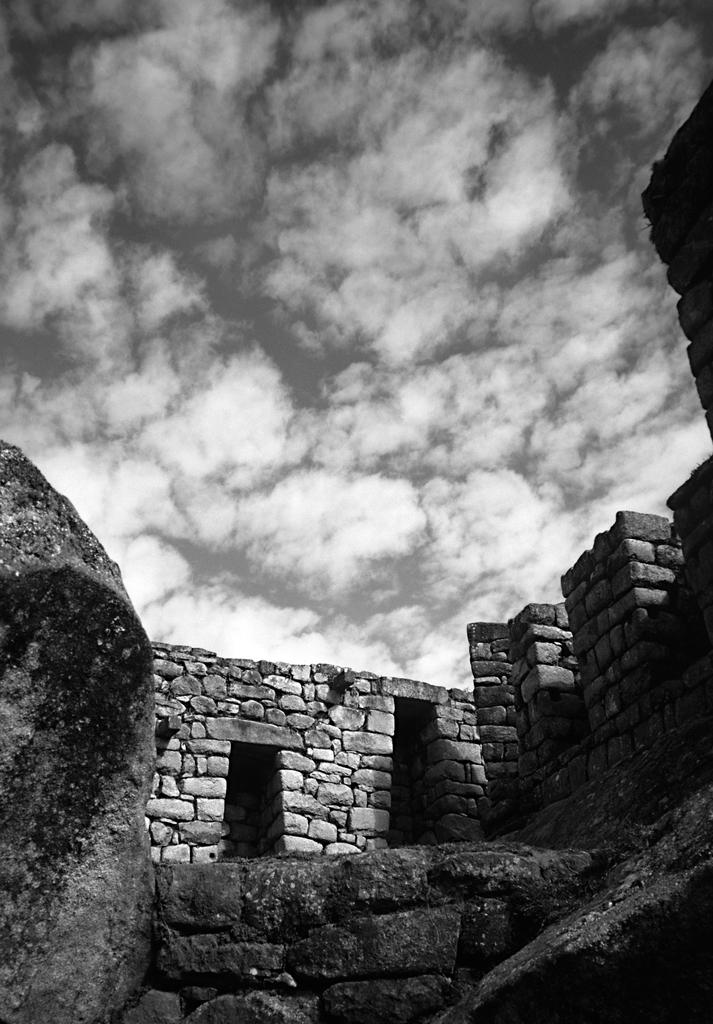What is the color scheme of the image? The image is black and white. What type of structure can be seen in the image? There is an ancient building in the image. What can be seen in the background of the image? The sky is visible in the background of the image. What is the condition of the sky in the image? Clouds are present in the sky. What type of feather can be seen floating near the ancient building in the image? There is no feather present in the image. What type of science is being conducted in the image? There is no indication of any scientific activity being conducted in the image. 